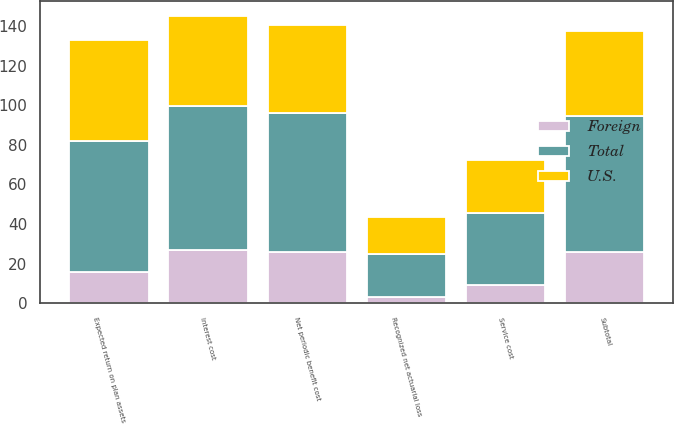<chart> <loc_0><loc_0><loc_500><loc_500><stacked_bar_chart><ecel><fcel>Service cost<fcel>Interest cost<fcel>Expected return on plan assets<fcel>Recognized net actuarial loss<fcel>Subtotal<fcel>Net periodic benefit cost<nl><fcel>U.S.<fcel>26.9<fcel>45.8<fcel>51.1<fcel>18.4<fcel>43<fcel>44.2<nl><fcel>Foreign<fcel>9.3<fcel>26.9<fcel>15.5<fcel>3.3<fcel>25.9<fcel>26<nl><fcel>Total<fcel>36.2<fcel>72.7<fcel>66.6<fcel>21.7<fcel>68.9<fcel>70.2<nl></chart> 